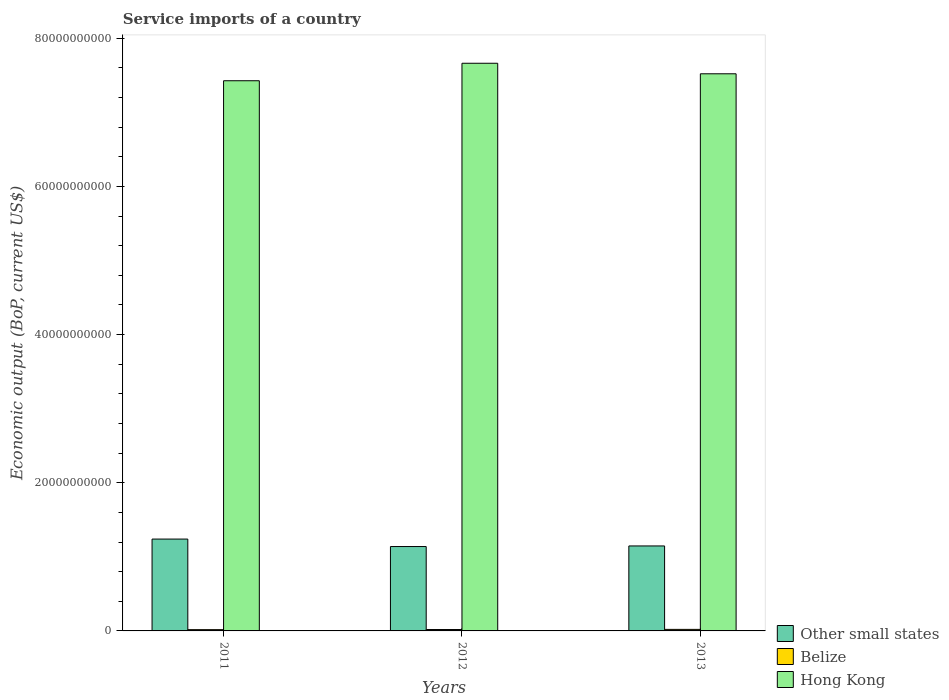How many different coloured bars are there?
Offer a terse response. 3. How many groups of bars are there?
Provide a succinct answer. 3. What is the service imports in Hong Kong in 2011?
Offer a terse response. 7.43e+1. Across all years, what is the maximum service imports in Belize?
Keep it short and to the point. 2.08e+08. Across all years, what is the minimum service imports in Other small states?
Offer a very short reply. 1.14e+1. What is the total service imports in Hong Kong in the graph?
Ensure brevity in your answer.  2.26e+11. What is the difference between the service imports in Other small states in 2011 and that in 2013?
Give a very brief answer. 9.28e+08. What is the difference between the service imports in Belize in 2011 and the service imports in Other small states in 2013?
Offer a terse response. -1.13e+1. What is the average service imports in Other small states per year?
Keep it short and to the point. 1.18e+1. In the year 2012, what is the difference between the service imports in Other small states and service imports in Hong Kong?
Your response must be concise. -6.52e+1. In how many years, is the service imports in Belize greater than 64000000000 US$?
Provide a succinct answer. 0. What is the ratio of the service imports in Other small states in 2011 to that in 2012?
Provide a short and direct response. 1.09. Is the difference between the service imports in Other small states in 2012 and 2013 greater than the difference between the service imports in Hong Kong in 2012 and 2013?
Give a very brief answer. No. What is the difference between the highest and the second highest service imports in Hong Kong?
Make the answer very short. 1.42e+09. What is the difference between the highest and the lowest service imports in Belize?
Give a very brief answer. 3.67e+07. In how many years, is the service imports in Hong Kong greater than the average service imports in Hong Kong taken over all years?
Offer a very short reply. 1. Is the sum of the service imports in Other small states in 2011 and 2013 greater than the maximum service imports in Hong Kong across all years?
Your answer should be very brief. No. What does the 1st bar from the left in 2012 represents?
Ensure brevity in your answer.  Other small states. What does the 3rd bar from the right in 2011 represents?
Give a very brief answer. Other small states. How many bars are there?
Offer a very short reply. 9. Are all the bars in the graph horizontal?
Ensure brevity in your answer.  No. Does the graph contain any zero values?
Your response must be concise. No. Where does the legend appear in the graph?
Your answer should be compact. Bottom right. How many legend labels are there?
Give a very brief answer. 3. What is the title of the graph?
Offer a very short reply. Service imports of a country. What is the label or title of the X-axis?
Keep it short and to the point. Years. What is the label or title of the Y-axis?
Provide a short and direct response. Economic output (BoP, current US$). What is the Economic output (BoP, current US$) of Other small states in 2011?
Give a very brief answer. 1.24e+1. What is the Economic output (BoP, current US$) of Belize in 2011?
Your answer should be compact. 1.71e+08. What is the Economic output (BoP, current US$) in Hong Kong in 2011?
Your response must be concise. 7.43e+1. What is the Economic output (BoP, current US$) in Other small states in 2012?
Ensure brevity in your answer.  1.14e+1. What is the Economic output (BoP, current US$) of Belize in 2012?
Ensure brevity in your answer.  1.88e+08. What is the Economic output (BoP, current US$) of Hong Kong in 2012?
Give a very brief answer. 7.66e+1. What is the Economic output (BoP, current US$) in Other small states in 2013?
Your answer should be compact. 1.15e+1. What is the Economic output (BoP, current US$) in Belize in 2013?
Provide a succinct answer. 2.08e+08. What is the Economic output (BoP, current US$) of Hong Kong in 2013?
Ensure brevity in your answer.  7.52e+1. Across all years, what is the maximum Economic output (BoP, current US$) in Other small states?
Offer a terse response. 1.24e+1. Across all years, what is the maximum Economic output (BoP, current US$) of Belize?
Ensure brevity in your answer.  2.08e+08. Across all years, what is the maximum Economic output (BoP, current US$) of Hong Kong?
Provide a succinct answer. 7.66e+1. Across all years, what is the minimum Economic output (BoP, current US$) in Other small states?
Offer a very short reply. 1.14e+1. Across all years, what is the minimum Economic output (BoP, current US$) in Belize?
Keep it short and to the point. 1.71e+08. Across all years, what is the minimum Economic output (BoP, current US$) of Hong Kong?
Give a very brief answer. 7.43e+1. What is the total Economic output (BoP, current US$) in Other small states in the graph?
Give a very brief answer. 3.53e+1. What is the total Economic output (BoP, current US$) in Belize in the graph?
Make the answer very short. 5.67e+08. What is the total Economic output (BoP, current US$) in Hong Kong in the graph?
Give a very brief answer. 2.26e+11. What is the difference between the Economic output (BoP, current US$) in Other small states in 2011 and that in 2012?
Your answer should be very brief. 1.01e+09. What is the difference between the Economic output (BoP, current US$) in Belize in 2011 and that in 2012?
Your response must be concise. -1.70e+07. What is the difference between the Economic output (BoP, current US$) of Hong Kong in 2011 and that in 2012?
Your answer should be very brief. -2.36e+09. What is the difference between the Economic output (BoP, current US$) of Other small states in 2011 and that in 2013?
Give a very brief answer. 9.28e+08. What is the difference between the Economic output (BoP, current US$) in Belize in 2011 and that in 2013?
Provide a short and direct response. -3.67e+07. What is the difference between the Economic output (BoP, current US$) of Hong Kong in 2011 and that in 2013?
Ensure brevity in your answer.  -9.38e+08. What is the difference between the Economic output (BoP, current US$) in Other small states in 2012 and that in 2013?
Offer a terse response. -7.97e+07. What is the difference between the Economic output (BoP, current US$) in Belize in 2012 and that in 2013?
Offer a very short reply. -1.97e+07. What is the difference between the Economic output (BoP, current US$) of Hong Kong in 2012 and that in 2013?
Offer a terse response. 1.42e+09. What is the difference between the Economic output (BoP, current US$) of Other small states in 2011 and the Economic output (BoP, current US$) of Belize in 2012?
Provide a short and direct response. 1.22e+1. What is the difference between the Economic output (BoP, current US$) in Other small states in 2011 and the Economic output (BoP, current US$) in Hong Kong in 2012?
Provide a succinct answer. -6.42e+1. What is the difference between the Economic output (BoP, current US$) in Belize in 2011 and the Economic output (BoP, current US$) in Hong Kong in 2012?
Your answer should be very brief. -7.64e+1. What is the difference between the Economic output (BoP, current US$) in Other small states in 2011 and the Economic output (BoP, current US$) in Belize in 2013?
Give a very brief answer. 1.22e+1. What is the difference between the Economic output (BoP, current US$) of Other small states in 2011 and the Economic output (BoP, current US$) of Hong Kong in 2013?
Offer a very short reply. -6.28e+1. What is the difference between the Economic output (BoP, current US$) of Belize in 2011 and the Economic output (BoP, current US$) of Hong Kong in 2013?
Keep it short and to the point. -7.50e+1. What is the difference between the Economic output (BoP, current US$) of Other small states in 2012 and the Economic output (BoP, current US$) of Belize in 2013?
Your answer should be compact. 1.12e+1. What is the difference between the Economic output (BoP, current US$) in Other small states in 2012 and the Economic output (BoP, current US$) in Hong Kong in 2013?
Provide a short and direct response. -6.38e+1. What is the difference between the Economic output (BoP, current US$) in Belize in 2012 and the Economic output (BoP, current US$) in Hong Kong in 2013?
Your answer should be compact. -7.50e+1. What is the average Economic output (BoP, current US$) in Other small states per year?
Give a very brief answer. 1.18e+1. What is the average Economic output (BoP, current US$) of Belize per year?
Offer a terse response. 1.89e+08. What is the average Economic output (BoP, current US$) of Hong Kong per year?
Offer a terse response. 7.54e+1. In the year 2011, what is the difference between the Economic output (BoP, current US$) in Other small states and Economic output (BoP, current US$) in Belize?
Give a very brief answer. 1.22e+1. In the year 2011, what is the difference between the Economic output (BoP, current US$) of Other small states and Economic output (BoP, current US$) of Hong Kong?
Your answer should be compact. -6.19e+1. In the year 2011, what is the difference between the Economic output (BoP, current US$) in Belize and Economic output (BoP, current US$) in Hong Kong?
Your response must be concise. -7.41e+1. In the year 2012, what is the difference between the Economic output (BoP, current US$) in Other small states and Economic output (BoP, current US$) in Belize?
Ensure brevity in your answer.  1.12e+1. In the year 2012, what is the difference between the Economic output (BoP, current US$) in Other small states and Economic output (BoP, current US$) in Hong Kong?
Your response must be concise. -6.52e+1. In the year 2012, what is the difference between the Economic output (BoP, current US$) in Belize and Economic output (BoP, current US$) in Hong Kong?
Provide a short and direct response. -7.64e+1. In the year 2013, what is the difference between the Economic output (BoP, current US$) of Other small states and Economic output (BoP, current US$) of Belize?
Your answer should be compact. 1.13e+1. In the year 2013, what is the difference between the Economic output (BoP, current US$) in Other small states and Economic output (BoP, current US$) in Hong Kong?
Your response must be concise. -6.37e+1. In the year 2013, what is the difference between the Economic output (BoP, current US$) of Belize and Economic output (BoP, current US$) of Hong Kong?
Your answer should be very brief. -7.50e+1. What is the ratio of the Economic output (BoP, current US$) of Other small states in 2011 to that in 2012?
Provide a short and direct response. 1.09. What is the ratio of the Economic output (BoP, current US$) of Belize in 2011 to that in 2012?
Offer a terse response. 0.91. What is the ratio of the Economic output (BoP, current US$) in Hong Kong in 2011 to that in 2012?
Your answer should be compact. 0.97. What is the ratio of the Economic output (BoP, current US$) of Other small states in 2011 to that in 2013?
Provide a succinct answer. 1.08. What is the ratio of the Economic output (BoP, current US$) of Belize in 2011 to that in 2013?
Provide a short and direct response. 0.82. What is the ratio of the Economic output (BoP, current US$) in Hong Kong in 2011 to that in 2013?
Keep it short and to the point. 0.99. What is the ratio of the Economic output (BoP, current US$) in Belize in 2012 to that in 2013?
Offer a terse response. 0.91. What is the ratio of the Economic output (BoP, current US$) in Hong Kong in 2012 to that in 2013?
Provide a succinct answer. 1.02. What is the difference between the highest and the second highest Economic output (BoP, current US$) in Other small states?
Offer a very short reply. 9.28e+08. What is the difference between the highest and the second highest Economic output (BoP, current US$) in Belize?
Your response must be concise. 1.97e+07. What is the difference between the highest and the second highest Economic output (BoP, current US$) of Hong Kong?
Make the answer very short. 1.42e+09. What is the difference between the highest and the lowest Economic output (BoP, current US$) in Other small states?
Keep it short and to the point. 1.01e+09. What is the difference between the highest and the lowest Economic output (BoP, current US$) in Belize?
Provide a succinct answer. 3.67e+07. What is the difference between the highest and the lowest Economic output (BoP, current US$) in Hong Kong?
Give a very brief answer. 2.36e+09. 